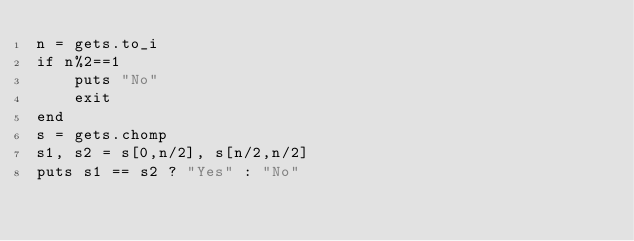<code> <loc_0><loc_0><loc_500><loc_500><_Ruby_>n = gets.to_i
if n%2==1
    puts "No"
    exit
end
s = gets.chomp
s1, s2 = s[0,n/2], s[n/2,n/2]
puts s1 == s2 ? "Yes" : "No"


</code> 